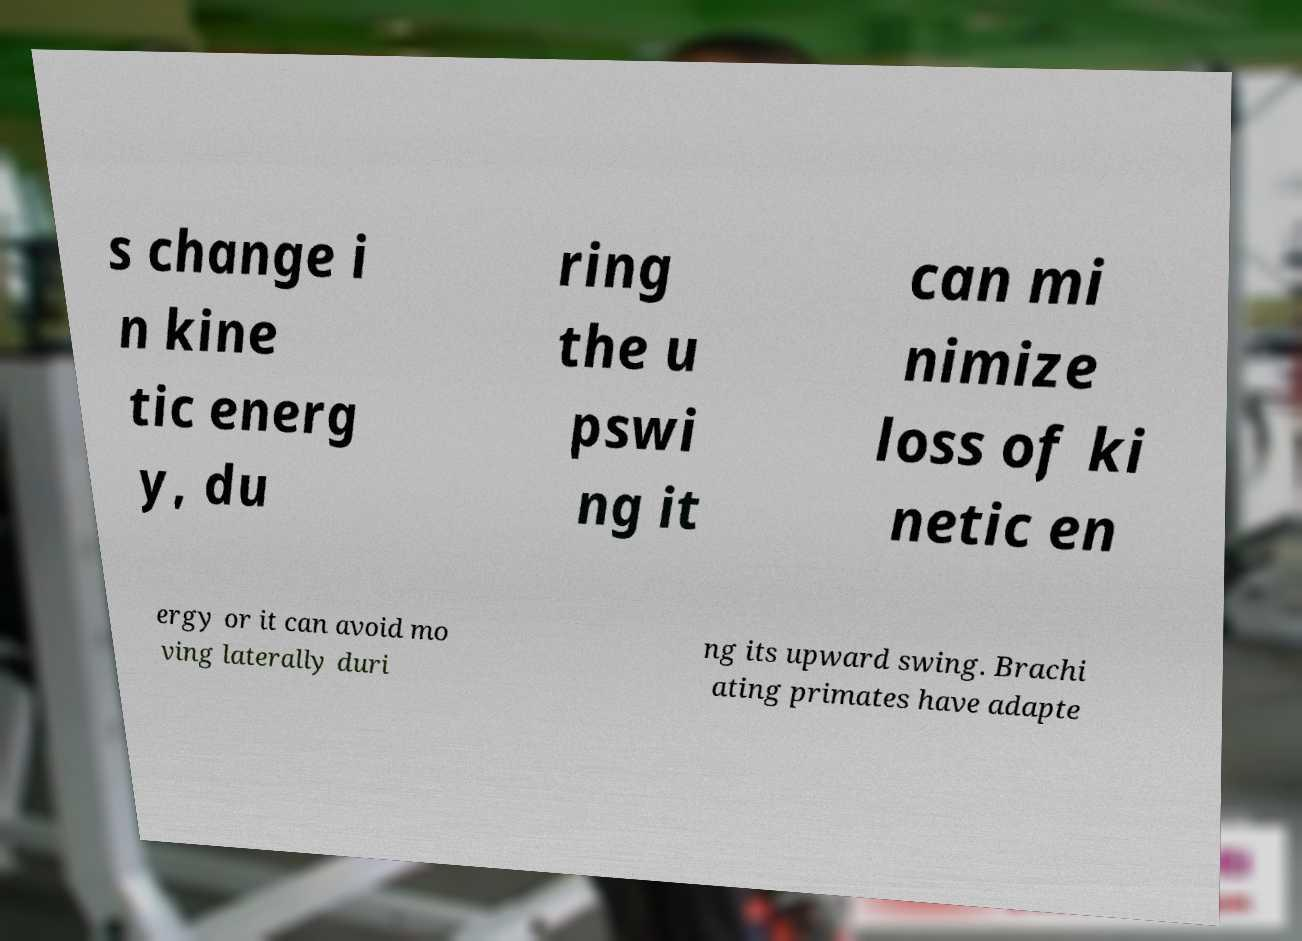What messages or text are displayed in this image? I need them in a readable, typed format. s change i n kine tic energ y, du ring the u pswi ng it can mi nimize loss of ki netic en ergy or it can avoid mo ving laterally duri ng its upward swing. Brachi ating primates have adapte 